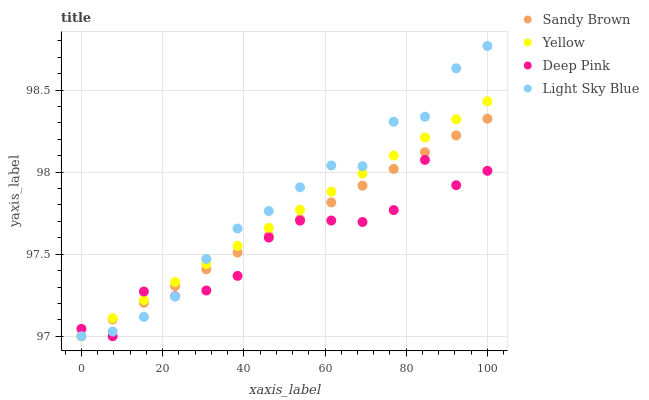Does Deep Pink have the minimum area under the curve?
Answer yes or no. Yes. Does Light Sky Blue have the maximum area under the curve?
Answer yes or no. Yes. Does Sandy Brown have the minimum area under the curve?
Answer yes or no. No. Does Sandy Brown have the maximum area under the curve?
Answer yes or no. No. Is Yellow the smoothest?
Answer yes or no. Yes. Is Deep Pink the roughest?
Answer yes or no. Yes. Is Sandy Brown the smoothest?
Answer yes or no. No. Is Sandy Brown the roughest?
Answer yes or no. No. Does Deep Pink have the lowest value?
Answer yes or no. Yes. Does Light Sky Blue have the highest value?
Answer yes or no. Yes. Does Sandy Brown have the highest value?
Answer yes or no. No. Does Yellow intersect Light Sky Blue?
Answer yes or no. Yes. Is Yellow less than Light Sky Blue?
Answer yes or no. No. Is Yellow greater than Light Sky Blue?
Answer yes or no. No. 